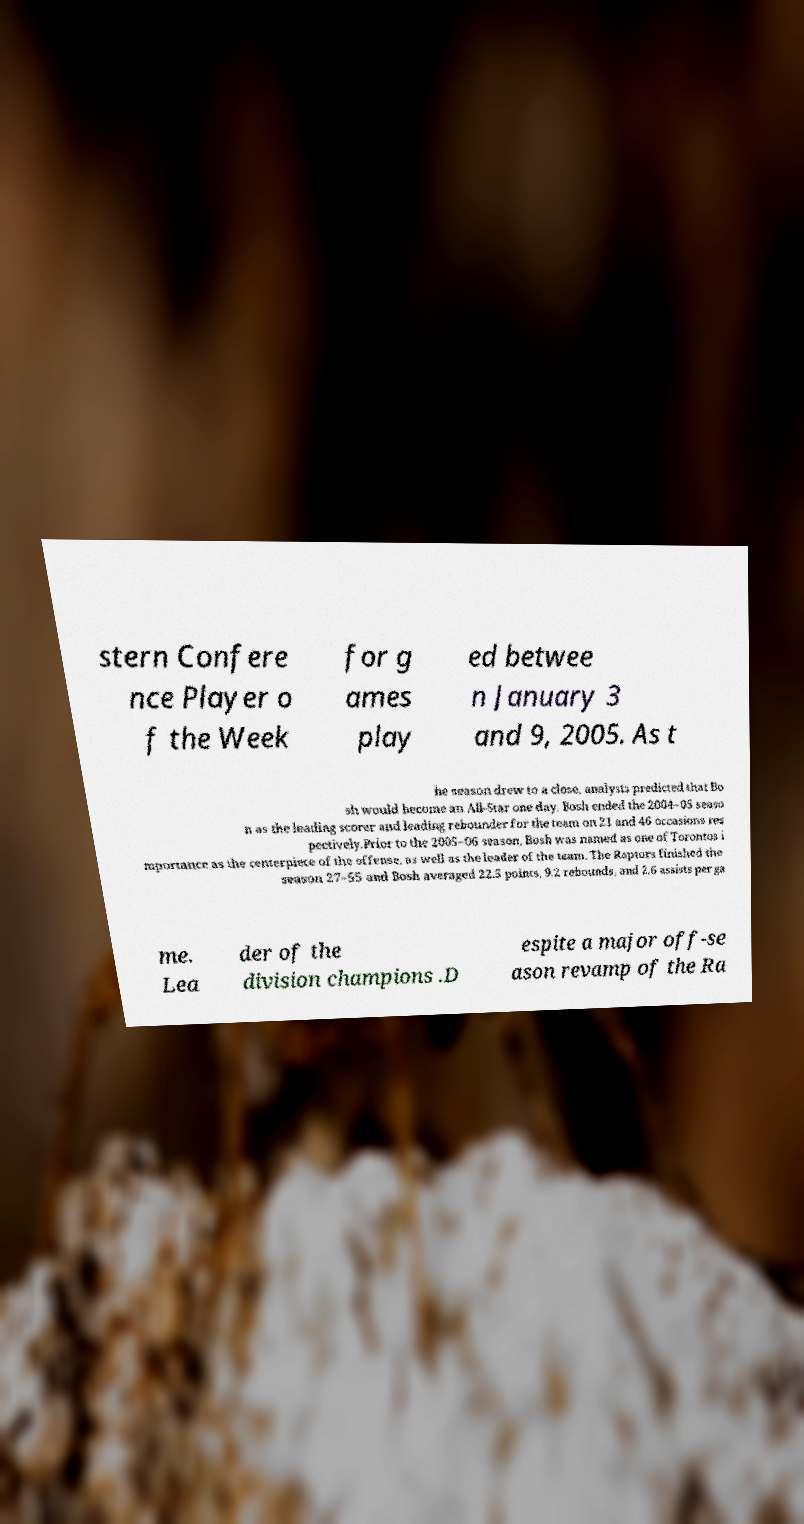There's text embedded in this image that I need extracted. Can you transcribe it verbatim? stern Confere nce Player o f the Week for g ames play ed betwee n January 3 and 9, 2005. As t he season drew to a close, analysts predicted that Bo sh would become an All-Star one day. Bosh ended the 2004–05 seaso n as the leading scorer and leading rebounder for the team on 21 and 46 occasions res pectively.Prior to the 2005–06 season, Bosh was named as one of Torontos i mportance as the centerpiece of the offense, as well as the leader of the team. The Raptors finished the season 27–55 and Bosh averaged 22.5 points, 9.2 rebounds, and 2.6 assists per ga me. Lea der of the division champions .D espite a major off-se ason revamp of the Ra 